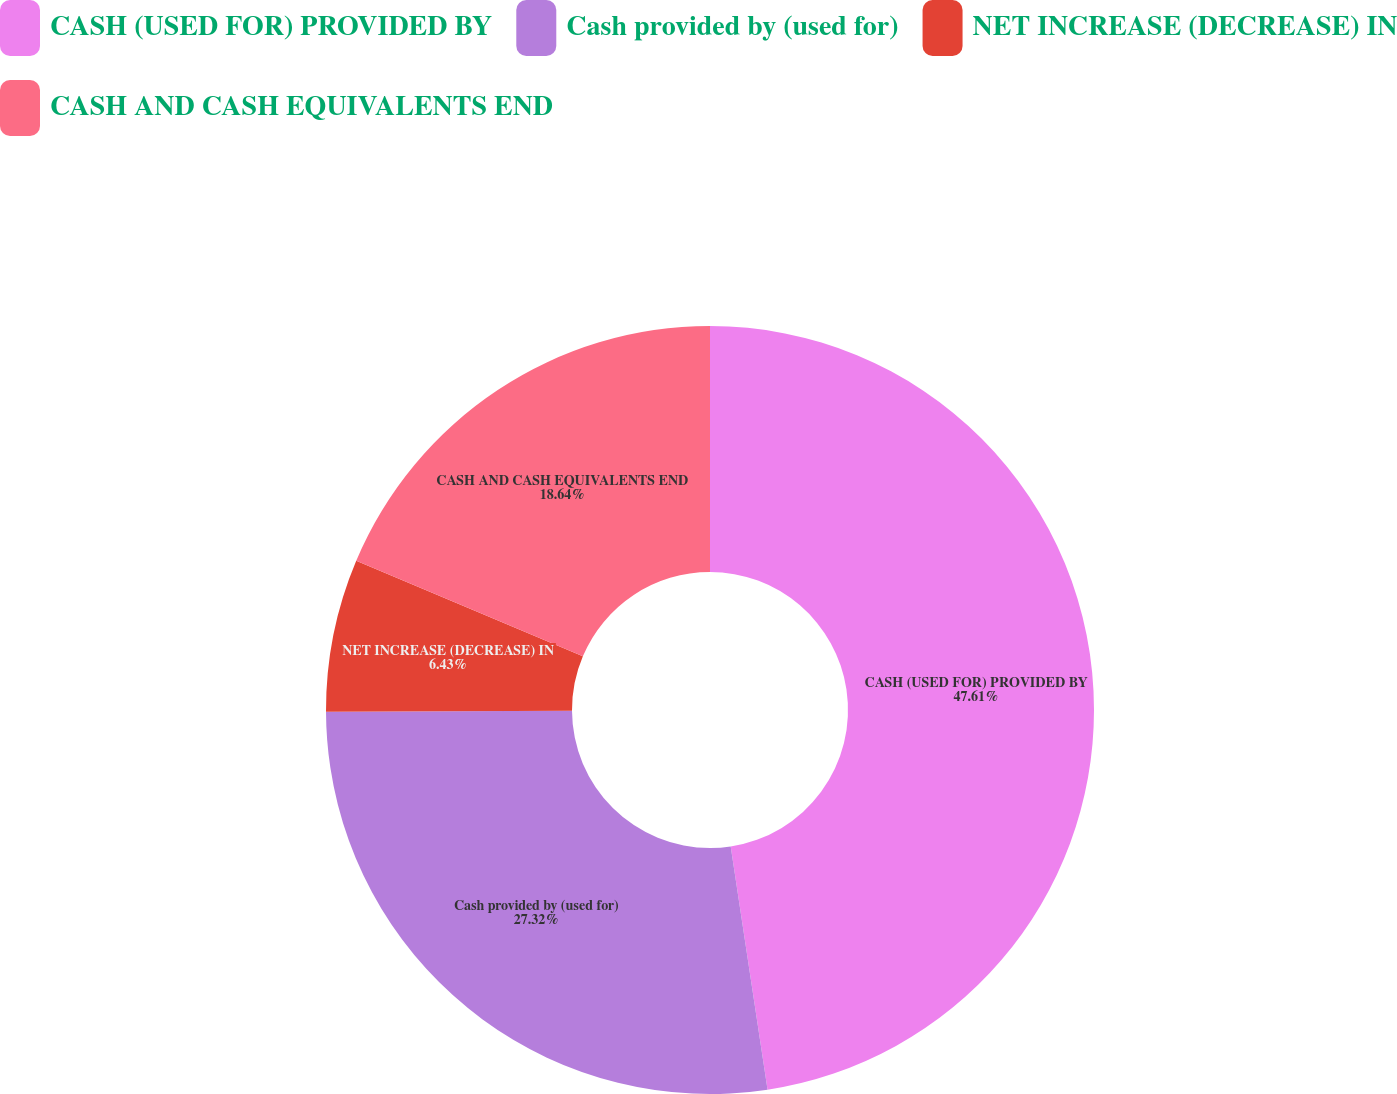<chart> <loc_0><loc_0><loc_500><loc_500><pie_chart><fcel>CASH (USED FOR) PROVIDED BY<fcel>Cash provided by (used for)<fcel>NET INCREASE (DECREASE) IN<fcel>CASH AND CASH EQUIVALENTS END<nl><fcel>47.6%<fcel>27.32%<fcel>6.43%<fcel>18.64%<nl></chart> 